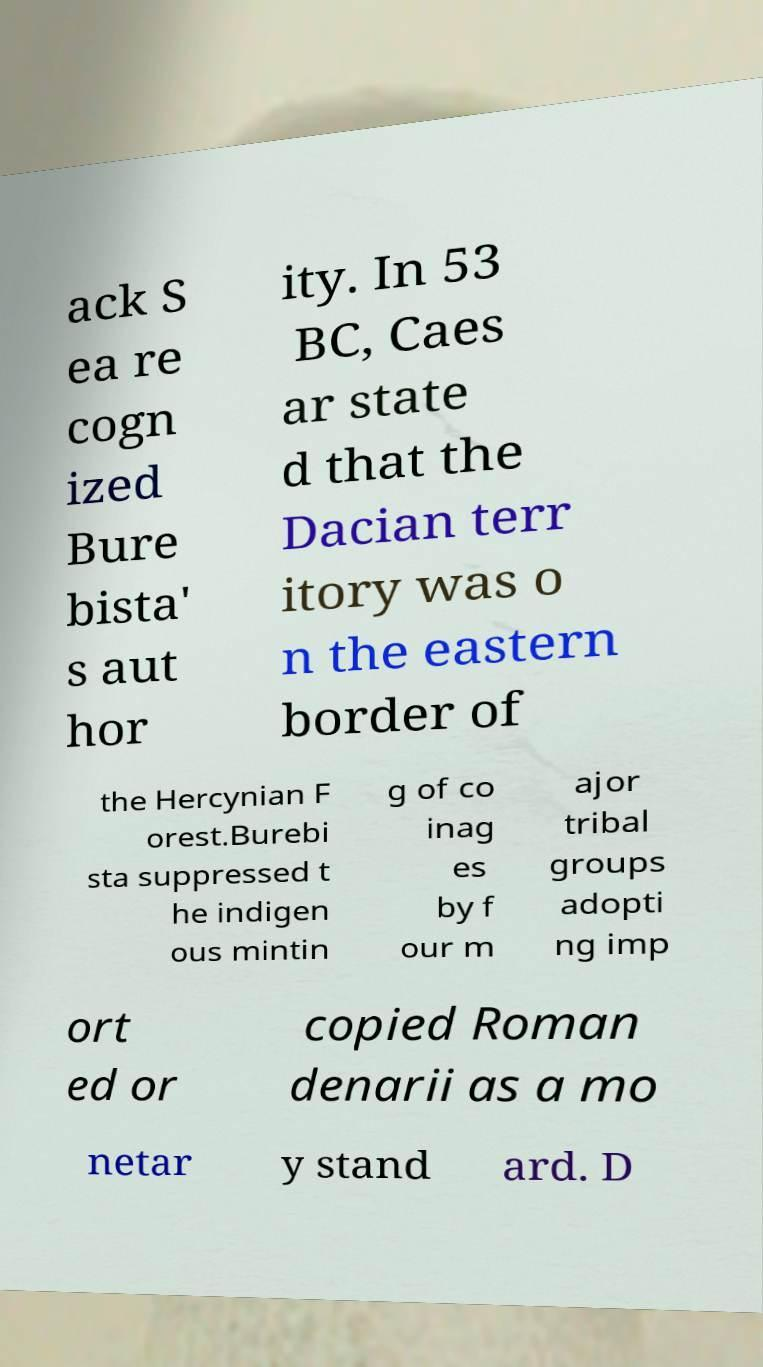Please read and relay the text visible in this image. What does it say? ack S ea re cogn ized Bure bista' s aut hor ity. In 53 BC, Caes ar state d that the Dacian terr itory was o n the eastern border of the Hercynian F orest.Burebi sta suppressed t he indigen ous mintin g of co inag es by f our m ajor tribal groups adopti ng imp ort ed or copied Roman denarii as a mo netar y stand ard. D 